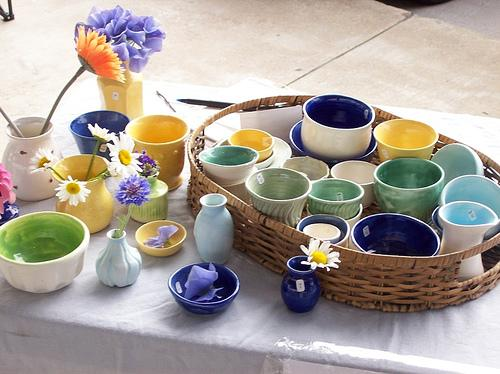How many of the vases are made from something other than glass?

Choices:
A) five
B) four
C) one
D) two two 